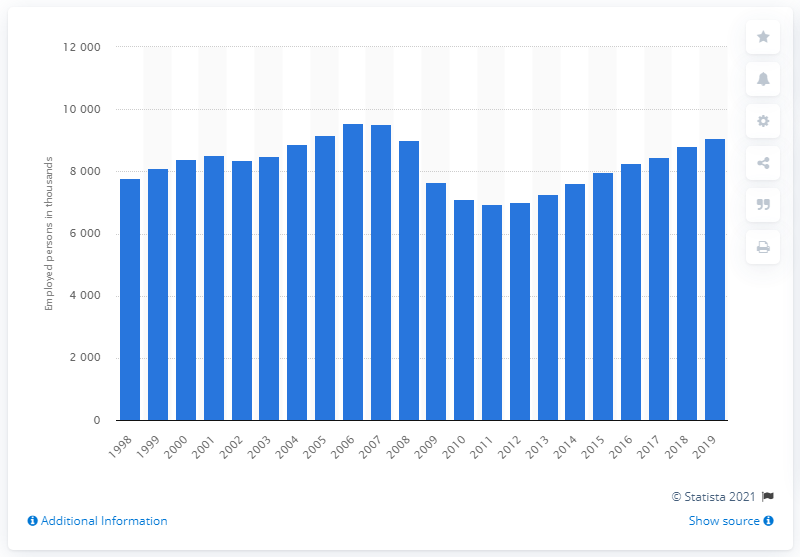Indicate a few pertinent items in this graphic. In the year 2008, the recession hit. 